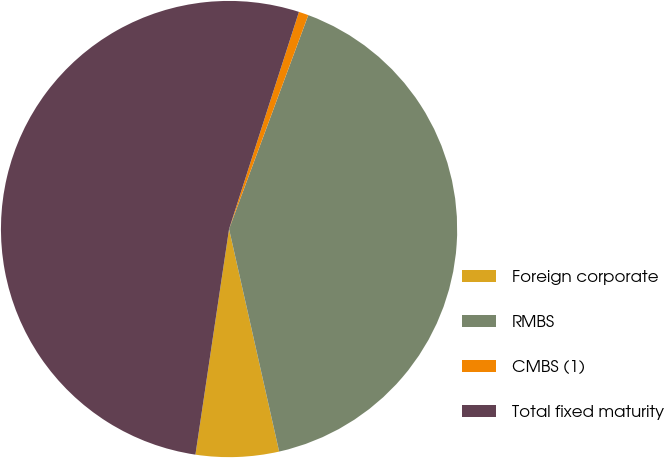Convert chart. <chart><loc_0><loc_0><loc_500><loc_500><pie_chart><fcel>Foreign corporate<fcel>RMBS<fcel>CMBS (1)<fcel>Total fixed maturity<nl><fcel>5.88%<fcel>40.83%<fcel>0.69%<fcel>52.6%<nl></chart> 